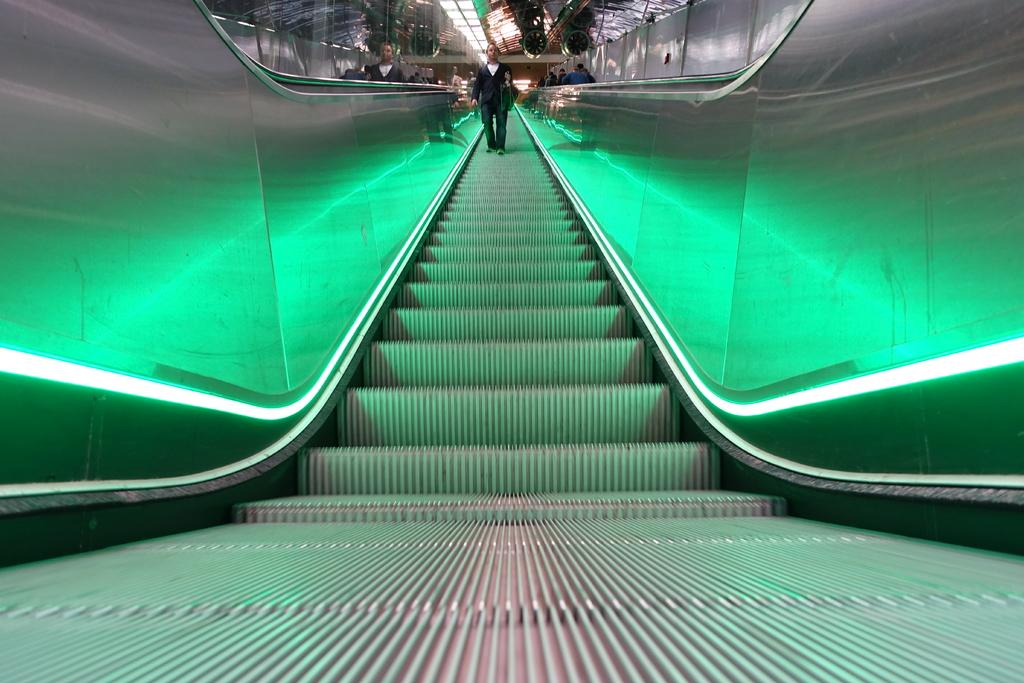What is the person in the image doing? The person is standing on an escalator. What can be seen in the background of the image? There are lights, walls, objects, and people in the background of the image. What type of hole can be seen in the image? There is no hole present in the image. What sound can be heard coming from the sky in the image? There is no sound mentioned in the image, and the presence of thunder cannot be determined. 